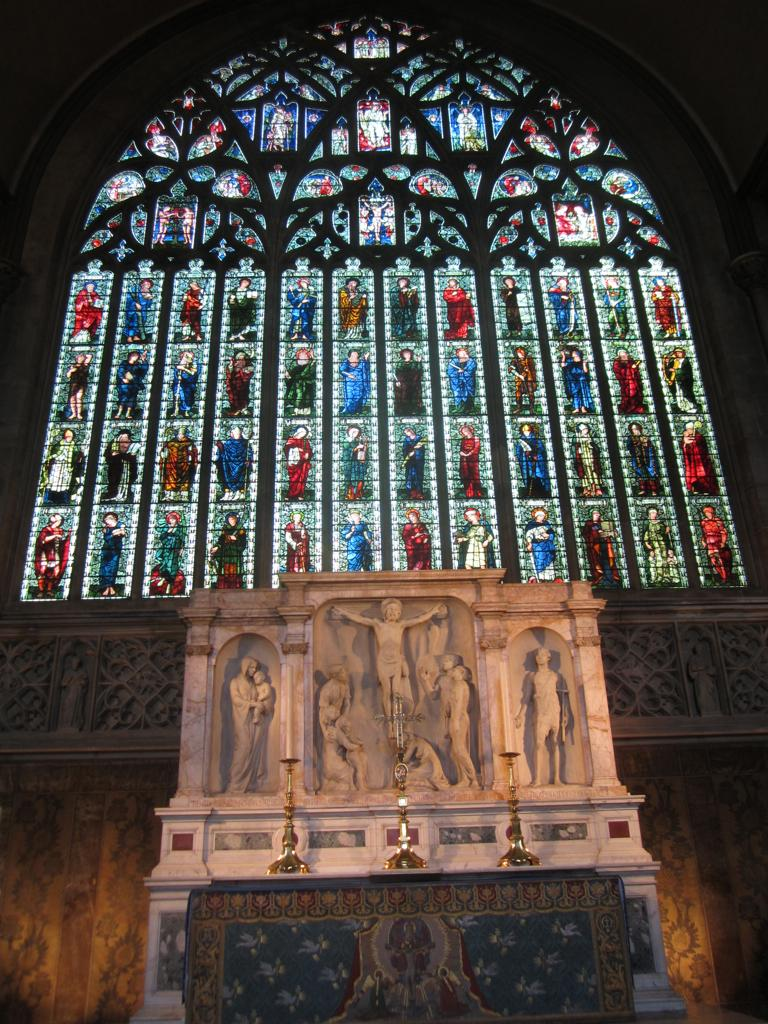What can be seen in the image that represents human-like figures? There are statues in the image that represent human-like figures. What else is present in the image besides the statues? There are objects in the image. What can be seen in the background of the image? There are pictures on a designed wall in the background of the image. What type of trousers is the scarecrow wearing in the image? There is no scarecrow present in the image, so it is not possible to determine what type of trousers it might be wearing. 